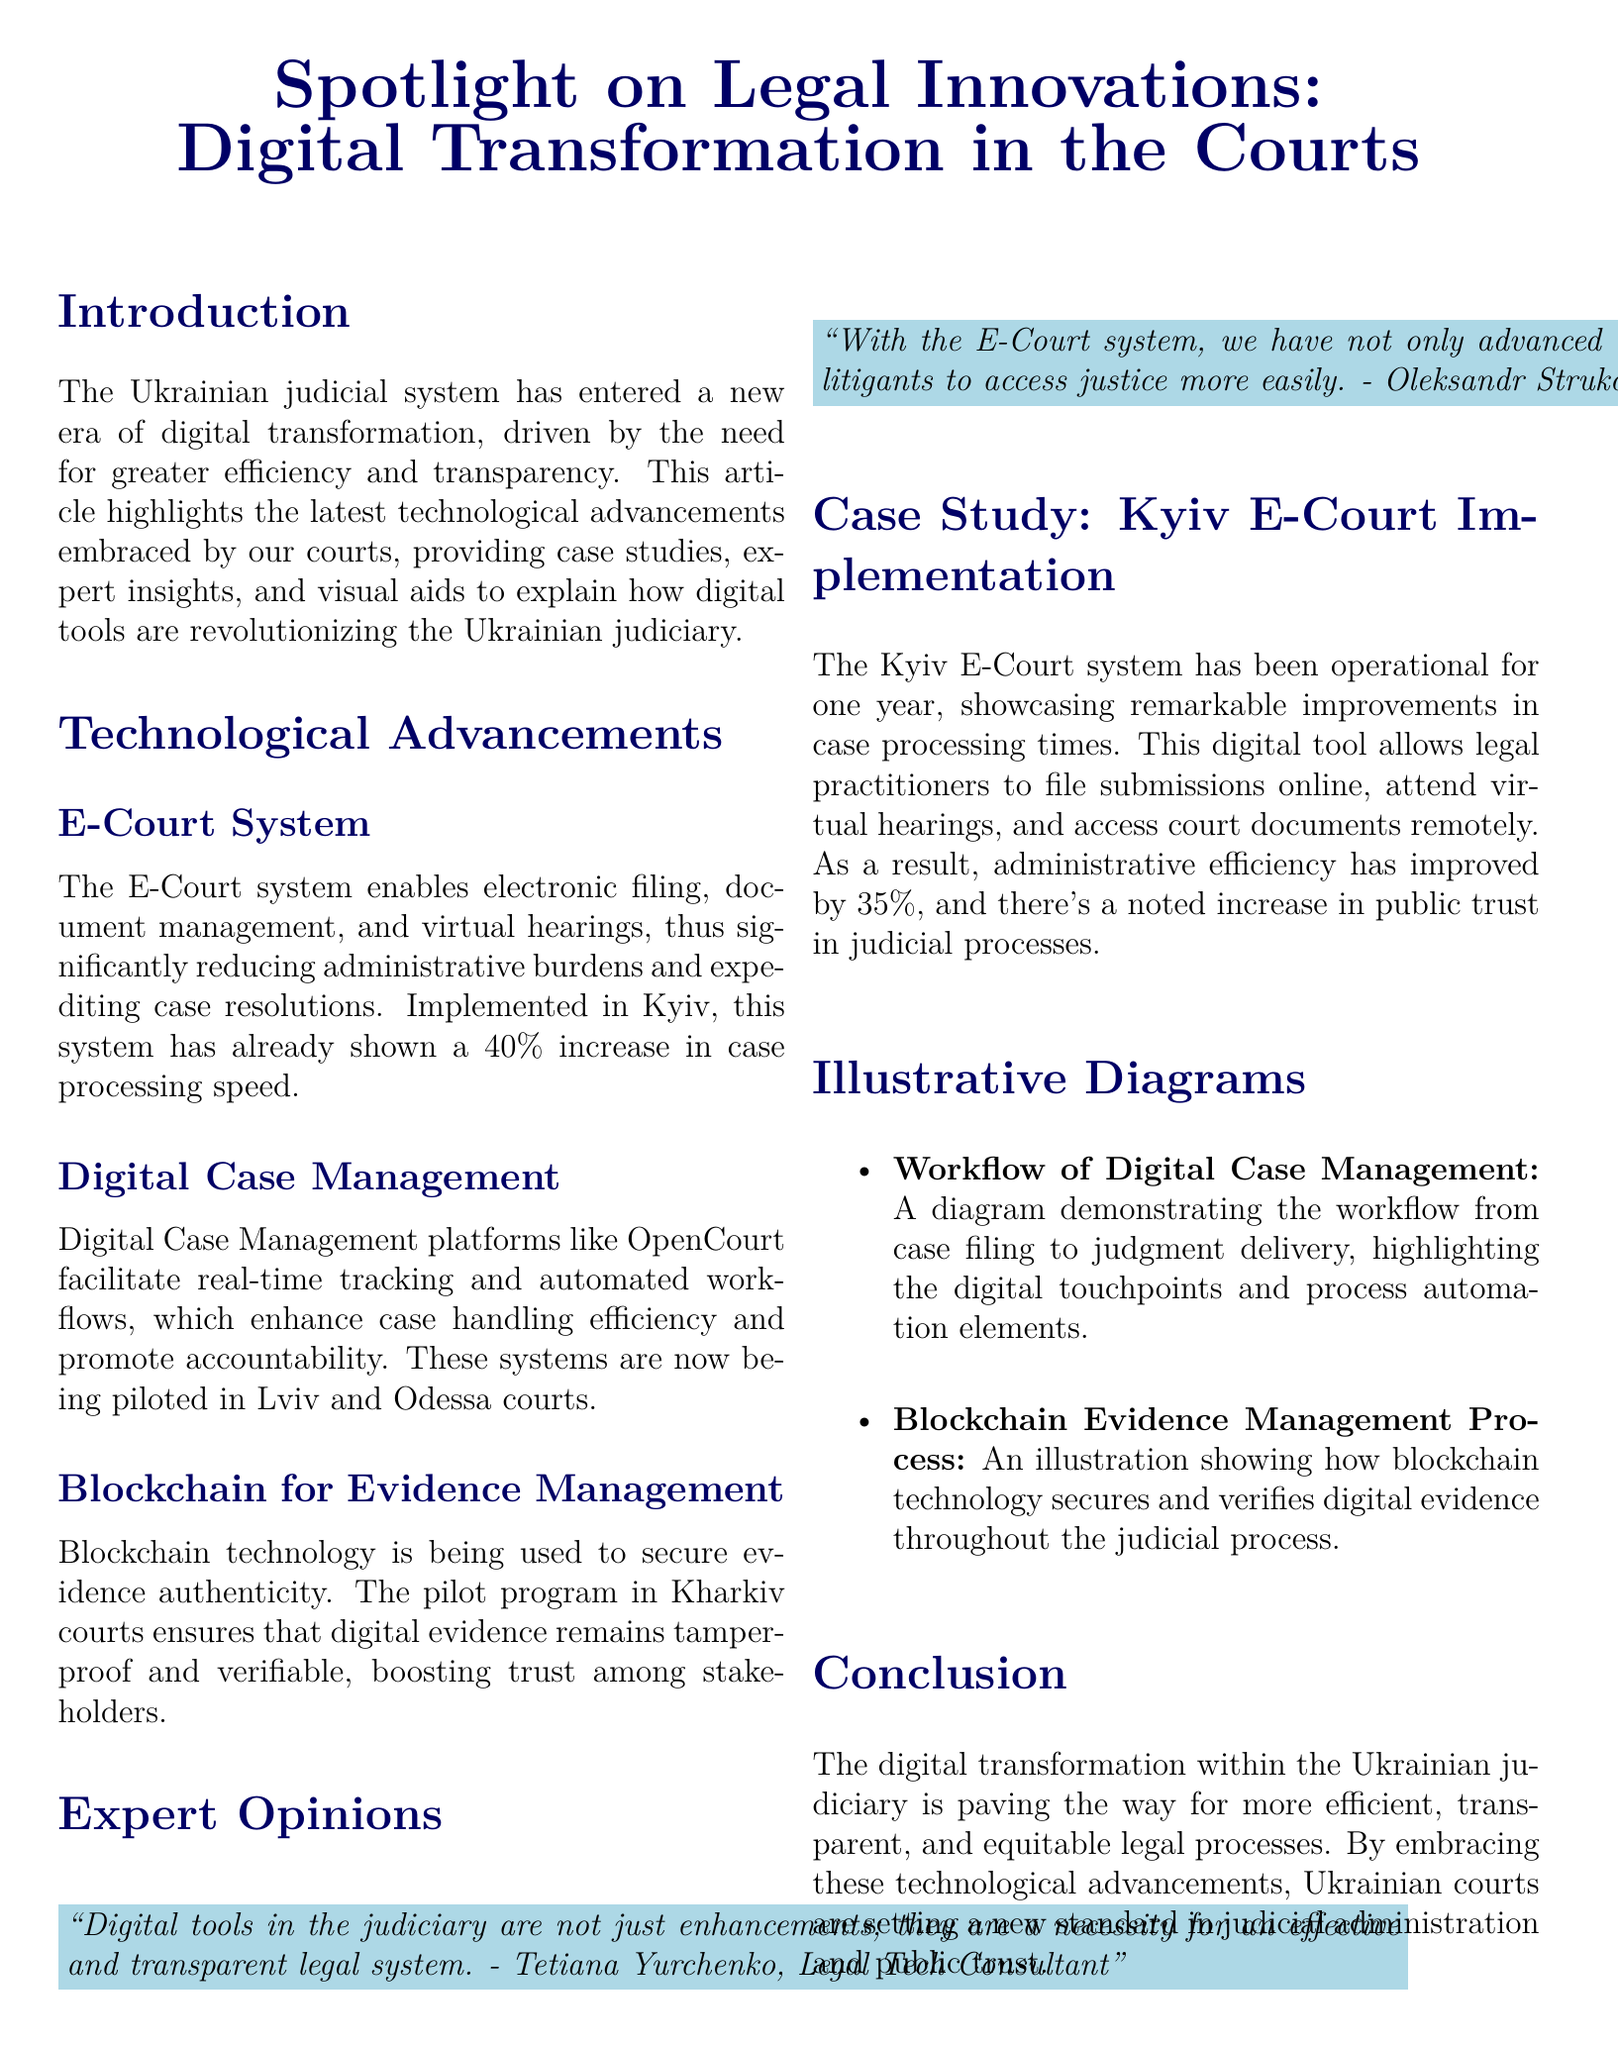What is the title of the article? The title of the article is presented prominently at the beginning of the document, highlighting its subject matter.
Answer: Spotlight on Legal Innovations: Digital Transformation in the Courts What percentage increase in case processing speed has the E-Court system shown? The document provides specific statistical data regarding the improvements made due to the E-Court system.
Answer: 40% Which two cities are mentioned as implementing Digital Case Management platforms? The cities where these platforms are being piloted are specified in the context of technological advancements.
Answer: Lviv and Odessa What is the purpose of blockchain technology in the judicial process? The document explains how blockchain is being utilized within the criminal justice system to enhance a specific aspect.
Answer: Secure evidence authenticity Who is quoted regarding the necessity of digital tools in the judiciary? A notable expert is cited in the document about the importance of digital tools for effectiveness in the legal system.
Answer: Tetiana Yurchenko What has improved by 35% due to the Kyiv E-Court system? The document details the specific administrative efficiency enhancement resulting from the system's implementation.
Answer: Administrative efficiency What is the main benefit mentioned about virtual hearings? The article describes the advantages brought by virtual hearings in the context of the E-Court system.
Answer: Empowering litigants to access justice more easily What is the focus of the "Illustrative Diagrams" section? This section includes descriptions of two visuals that support the text about the digital transformation in courts.
Answer: Diagrams demonstrating workflows and processes How long has the Kyiv E-Court system been operational? The document mentions the duration of the system's operation as part of its case study.
Answer: One year 